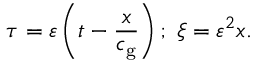Convert formula to latex. <formula><loc_0><loc_0><loc_500><loc_500>\tau = \varepsilon \left ( t - \frac { x } { c _ { g } } \right ) ; \, \xi = \varepsilon ^ { 2 } x .</formula> 